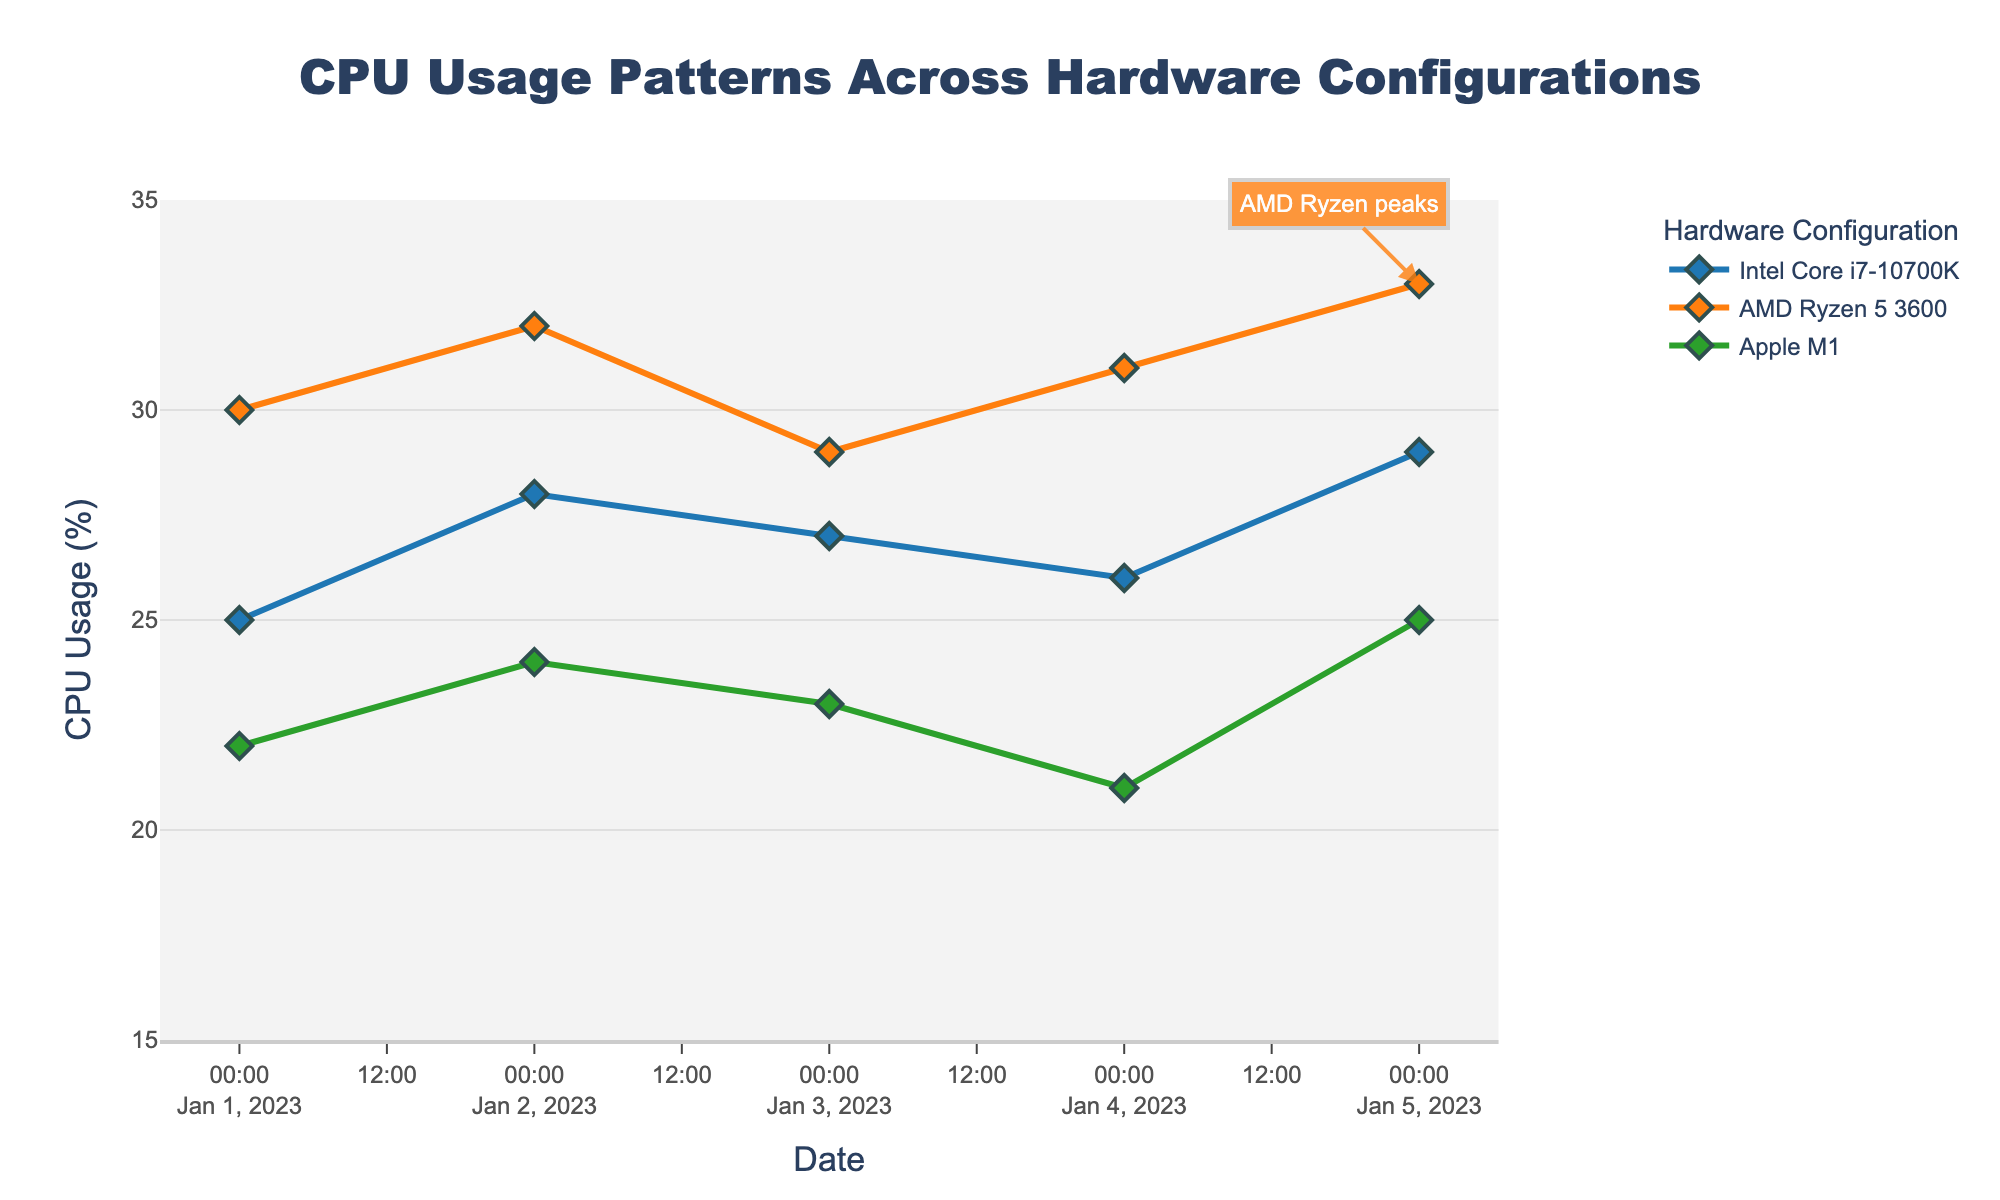What is the title of the plot? The title of the plot is usually displayed at the top of the figure. In this case, the title indicated is "CPU Usage Patterns Across Hardware Configurations".
Answer: CPU Usage Patterns Across Hardware Configurations Which hardware configuration shows the lowest CPU usage on January 1, 2023? By observing the data points for January 1, 2023, we see that the Apple M1 has the lowest CPU usage at 22%.
Answer: Apple M1 How many hardware configurations are compared in the plot? The plot contains data for three different hardware configurations, which are represented by different lines/colors. These configurations are Intel Core i7-10700K, AMD Ryzen 5 3600, and Apple M1.
Answer: 3 Which hardware configuration shows a peak annotation in the plot? The plot has an annotation pointing out the peak for one of the hardware configurations. The annotation label "AMD Ryzen peaks" indicates that the AMD Ryzen 5 3600 is the hardware configuration with the peak annotation.
Answer: AMD Ryzen 5 3600 What is the highest CPU usage recorded for Intel Core i7-10700K? To determine this, we look at the highest data point for Intel Core i7-10700K. The maximum recorded CPU usage is on January 5, 2023, with a CPU usage of 29%.
Answer: 29% Which date shows the highest CPU usage for Apple M1? By observing the trend for Apple M1, the date with the highest CPU usage is January 5, 2023, with a usage of 25%.
Answer: January 5, 2023 Which hardware configuration has the most consistent CPU usage pattern over the observed dates? To identify the most consistent pattern, we look for the line that changes the least over time. Apple M1 has the smallest variation (ranging from 21% to 25%), indicating the most consistent usage pattern.
Answer: Apple M1 Calculate the average CPU usage for AMD Ryzen 5 3600 over the dates provided. Sum the AMD Ryzen 5 3600 CPU usage values (30 + 32 + 29 + 31 + 33) and then divide by the number of days (5). The total is 155, and the average is 155 / 5 = 31%.
Answer: 31% On what date do all hardware configurations exhibit their lowest combined CPU usage? Calculate the sum of CPU usage for each date and identify the lowest total. January 4, 2023, has the lowest combined CPU usage (26 + 31 + 21 = 78).
Answer: January 4, 2023 